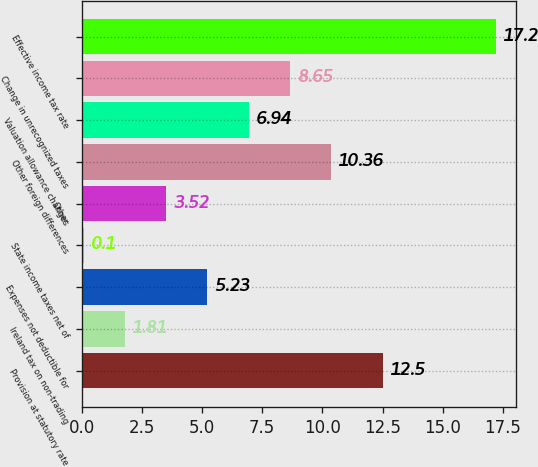Convert chart to OTSL. <chart><loc_0><loc_0><loc_500><loc_500><bar_chart><fcel>Provision at statutory rate<fcel>Ireland tax on non-trading<fcel>Expenses not deductible for<fcel>State income taxes net of<fcel>Other<fcel>Other foreign differences<fcel>Valuation allowance changes<fcel>Change in unrecognized taxes<fcel>Effective income tax rate<nl><fcel>12.5<fcel>1.81<fcel>5.23<fcel>0.1<fcel>3.52<fcel>10.36<fcel>6.94<fcel>8.65<fcel>17.2<nl></chart> 